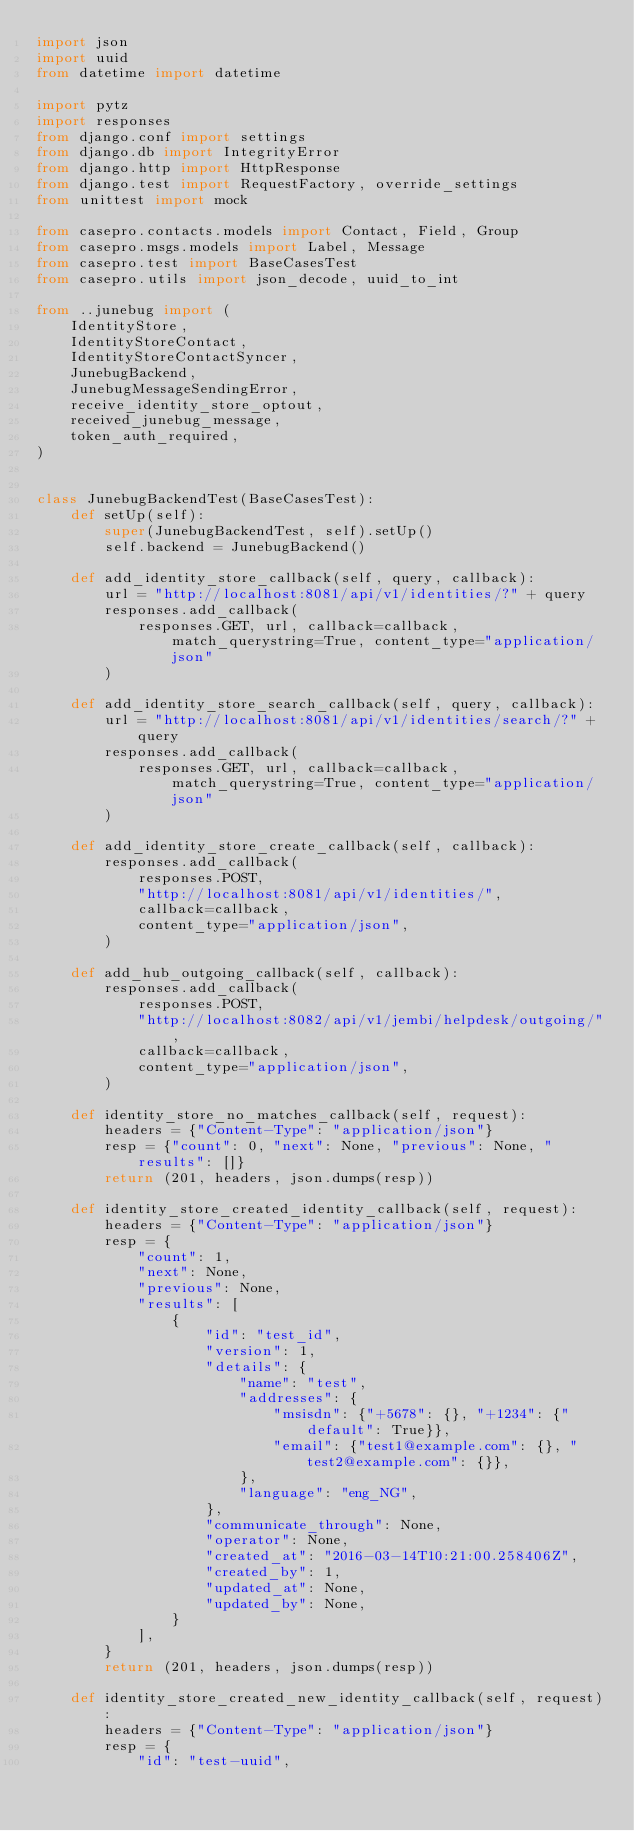Convert code to text. <code><loc_0><loc_0><loc_500><loc_500><_Python_>import json
import uuid
from datetime import datetime

import pytz
import responses
from django.conf import settings
from django.db import IntegrityError
from django.http import HttpResponse
from django.test import RequestFactory, override_settings
from unittest import mock

from casepro.contacts.models import Contact, Field, Group
from casepro.msgs.models import Label, Message
from casepro.test import BaseCasesTest
from casepro.utils import json_decode, uuid_to_int

from ..junebug import (
    IdentityStore,
    IdentityStoreContact,
    IdentityStoreContactSyncer,
    JunebugBackend,
    JunebugMessageSendingError,
    receive_identity_store_optout,
    received_junebug_message,
    token_auth_required,
)


class JunebugBackendTest(BaseCasesTest):
    def setUp(self):
        super(JunebugBackendTest, self).setUp()
        self.backend = JunebugBackend()

    def add_identity_store_callback(self, query, callback):
        url = "http://localhost:8081/api/v1/identities/?" + query
        responses.add_callback(
            responses.GET, url, callback=callback, match_querystring=True, content_type="application/json"
        )

    def add_identity_store_search_callback(self, query, callback):
        url = "http://localhost:8081/api/v1/identities/search/?" + query
        responses.add_callback(
            responses.GET, url, callback=callback, match_querystring=True, content_type="application/json"
        )

    def add_identity_store_create_callback(self, callback):
        responses.add_callback(
            responses.POST,
            "http://localhost:8081/api/v1/identities/",
            callback=callback,
            content_type="application/json",
        )

    def add_hub_outgoing_callback(self, callback):
        responses.add_callback(
            responses.POST,
            "http://localhost:8082/api/v1/jembi/helpdesk/outgoing/",
            callback=callback,
            content_type="application/json",
        )

    def identity_store_no_matches_callback(self, request):
        headers = {"Content-Type": "application/json"}
        resp = {"count": 0, "next": None, "previous": None, "results": []}
        return (201, headers, json.dumps(resp))

    def identity_store_created_identity_callback(self, request):
        headers = {"Content-Type": "application/json"}
        resp = {
            "count": 1,
            "next": None,
            "previous": None,
            "results": [
                {
                    "id": "test_id",
                    "version": 1,
                    "details": {
                        "name": "test",
                        "addresses": {
                            "msisdn": {"+5678": {}, "+1234": {"default": True}},
                            "email": {"test1@example.com": {}, "test2@example.com": {}},
                        },
                        "language": "eng_NG",
                    },
                    "communicate_through": None,
                    "operator": None,
                    "created_at": "2016-03-14T10:21:00.258406Z",
                    "created_by": 1,
                    "updated_at": None,
                    "updated_by": None,
                }
            ],
        }
        return (201, headers, json.dumps(resp))

    def identity_store_created_new_identity_callback(self, request):
        headers = {"Content-Type": "application/json"}
        resp = {
            "id": "test-uuid",</code> 